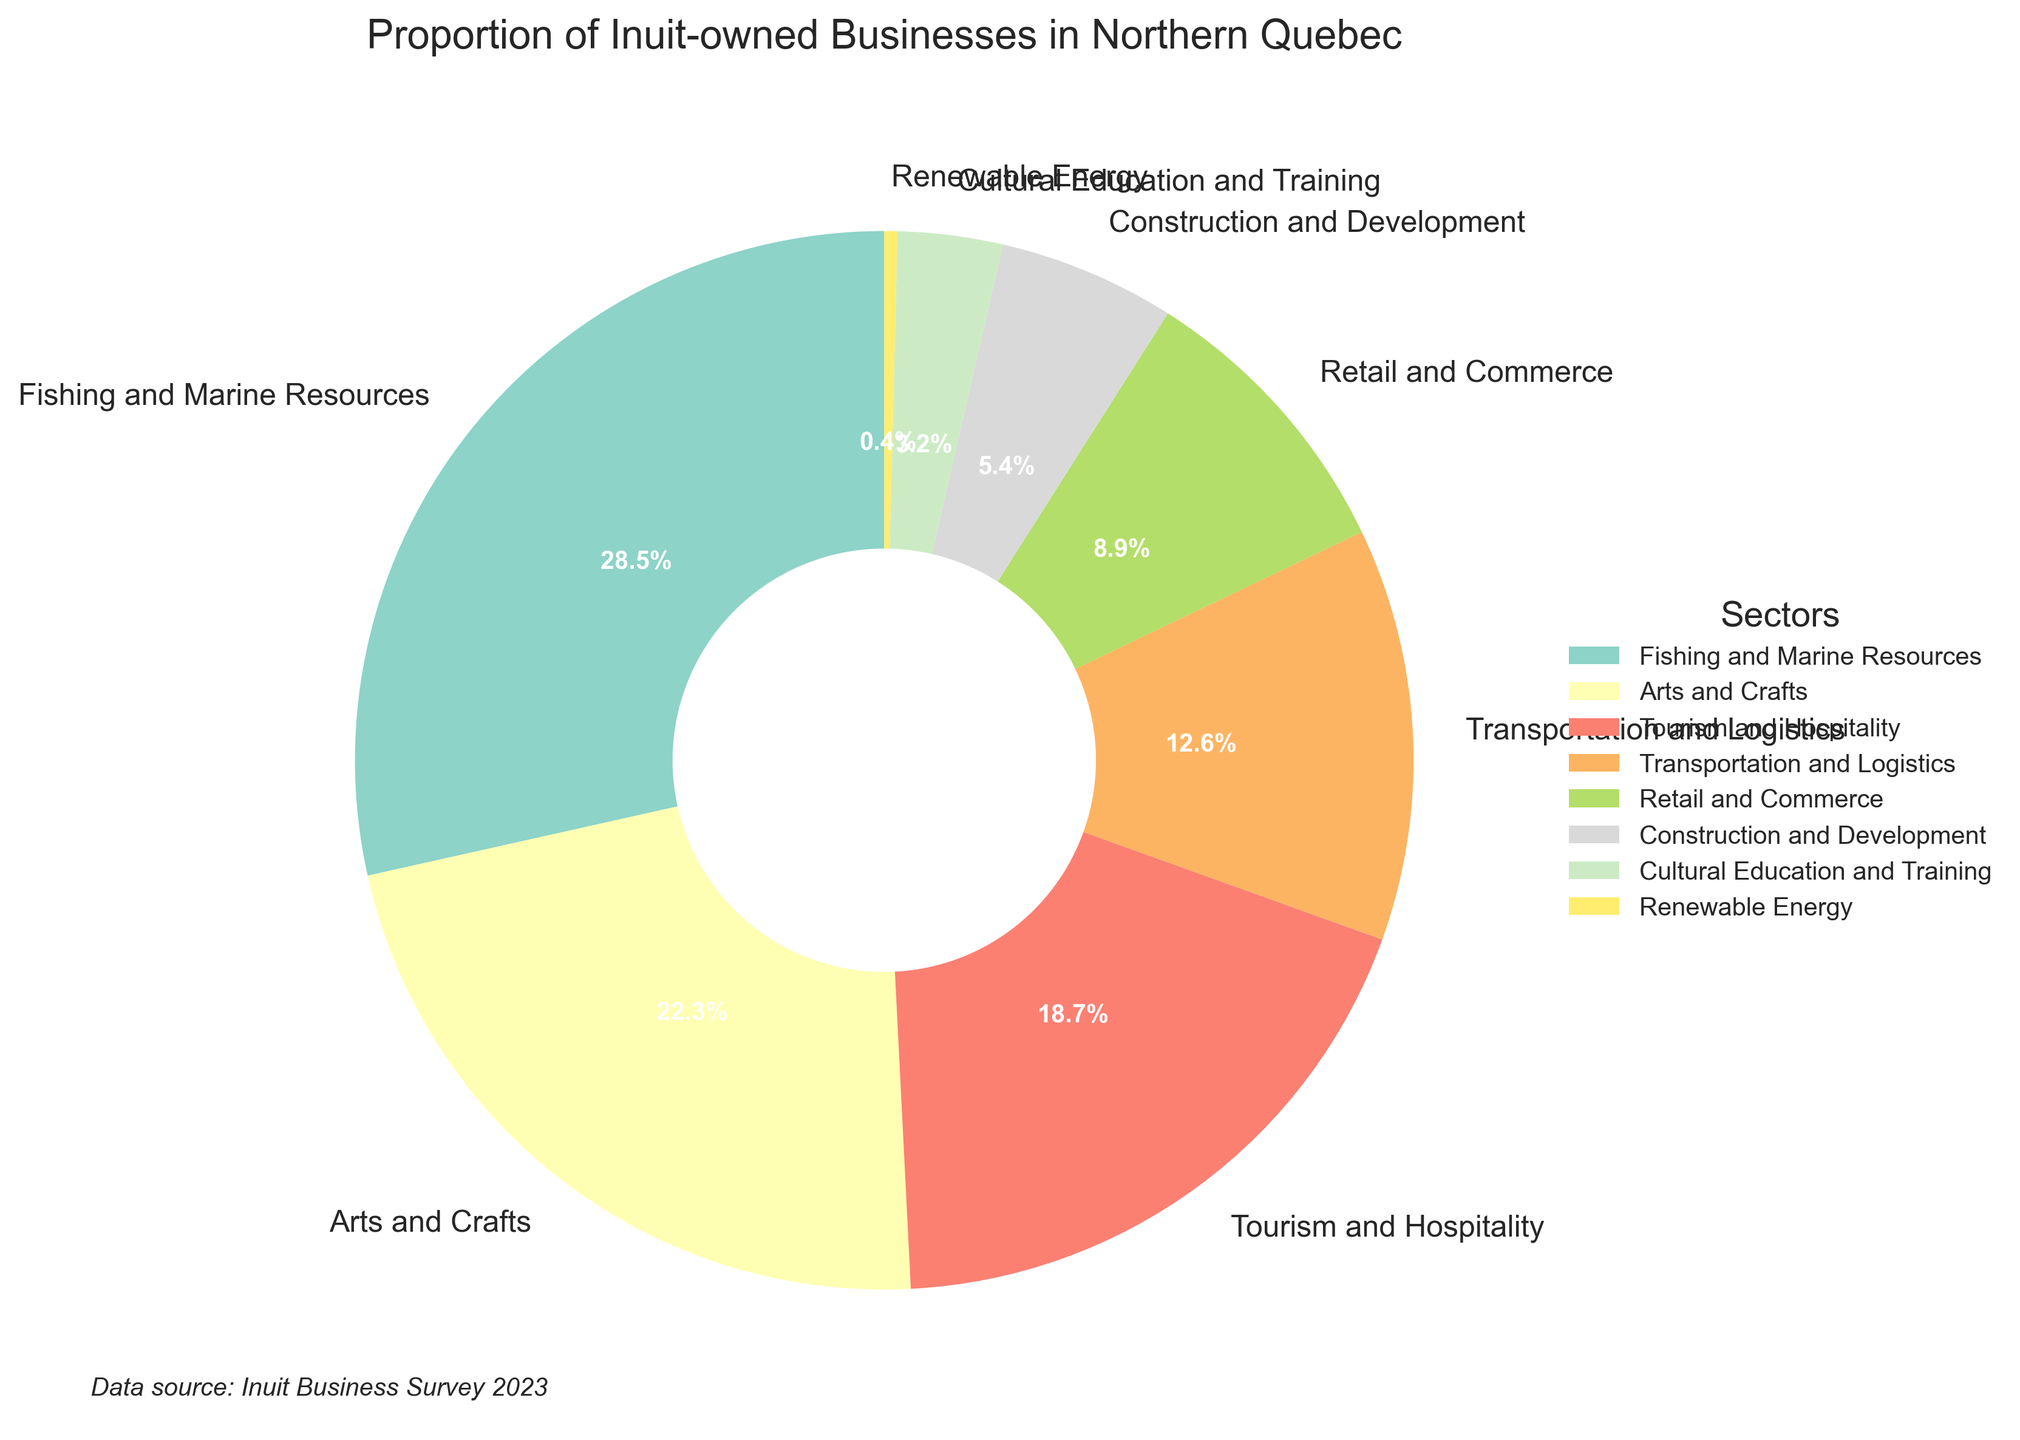What's the largest sector for Inuit-owned businesses? The figure shows a pie chart with different sectors labeled. The sector with the largest wedge is "Fishing and Marine Resources."
Answer: Fishing and Marine Resources Which sectors combined hold the second and third largest proportions? The second largest sector is "Arts and Crafts" and the third largest is "Tourism and Hospitality." Summing their percentages: 22.3% + 18.7% = 41.0%.
Answer: Arts and Crafts and Tourism and Hospitality Which sector has the smallest proportion, and what is its percentage? Looking at the smallest wedge in the pie chart, "Renewable Energy" has the smallest percentage of 0.4%.
Answer: Renewable Energy, 0.4% Are there more businesses in the Arts and Crafts sector or the Transportation and Logistics sector, and by how much? The pie chart shows that Arts and Crafts have 22.3% while Transportation and Logistics have 12.6%. The difference is 22.3% - 12.6% = 9.7%.
Answer: Arts and Crafts by 9.7% If you were to group the three smallest sectors, what would their combined percentage be? The three smallest sectors are "Renewable Energy" (0.4%), "Cultural Education and Training" (3.2%), and "Construction and Development" (5.4%). Summing them gives 0.4% + 3.2% + 5.4% = 9.0%.
Answer: 9.0% How does the proportion of businesses in the Retail and Commerce sector compare to those in the Construction and Development sector? The pie chart shows that "Retail and Commerce" is 8.9% and "Construction and Development" is 5.4%. Retail and Commerce is greater by 8.9% - 5.4% = 3.5%.
Answer: Retail and Commerce by 3.5% Which sectors have a proportion of businesses greater than 10%? The sectors greater than 10% are "Fishing and Marine Resources" (28.5%), "Arts and Crafts" (22.3%), "Tourism and Hospitality" (18.7%), and "Transportation and Logistics" (12.6%).
Answer: Fishing and Marine Resources, Arts and Crafts, Tourism and Hospitality, Transportation and Logistics What is the combined proportion of all sectors related to cultural activities (Arts and Crafts and Cultural Education and Training)? The pie chart shows "Arts and Crafts" is 22.3% and "Cultural Education and Training" is 3.2%. Combined, they are 22.3% + 3.2% = 25.5%.
Answer: 25.5% Is the proportion of businesses in Fishing and Marine Resources sector more than double than of Tourism and Hospitality? Fishing and Marine Resources is 28.5% and Tourism and Hospitality is 18.7%. Doubling 18.7% gives 37.4%, which is greater than 28.5%.
Answer: No 